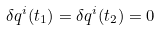Convert formula to latex. <formula><loc_0><loc_0><loc_500><loc_500>\delta q ^ { i } ( t _ { 1 } ) = \delta q ^ { i } ( t _ { 2 } ) = 0</formula> 